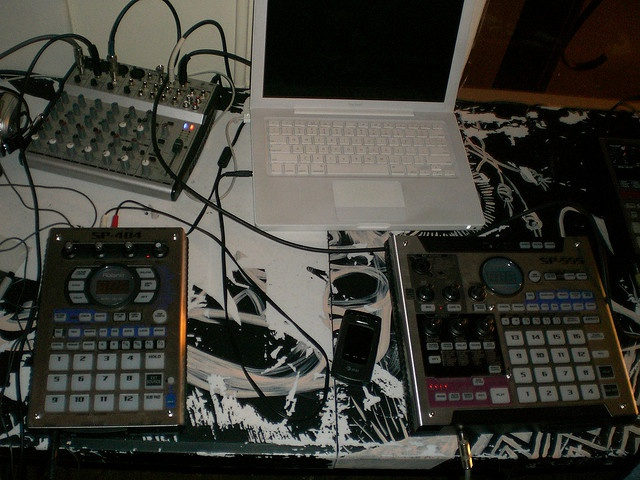Describe the objects in this image and their specific colors. I can see laptop in gray and black tones and cell phone in gray, black, and darkgray tones in this image. 